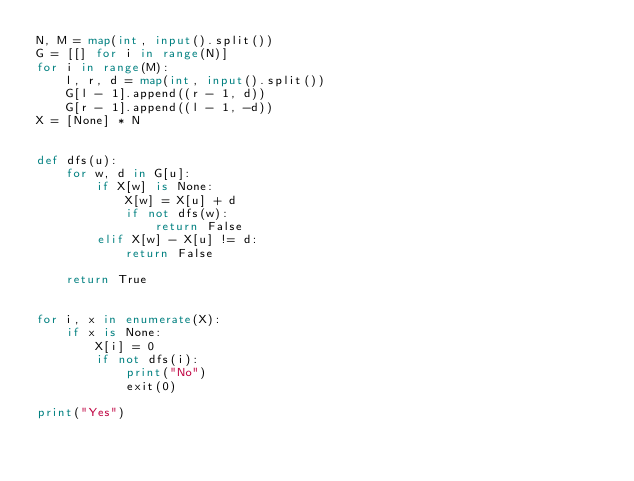Convert code to text. <code><loc_0><loc_0><loc_500><loc_500><_Python_>N, M = map(int, input().split())
G = [[] for i in range(N)]
for i in range(M):
    l, r, d = map(int, input().split())
    G[l - 1].append((r - 1, d))
    G[r - 1].append((l - 1, -d))
X = [None] * N


def dfs(u):
    for w, d in G[u]:
        if X[w] is None:
            X[w] = X[u] + d
            if not dfs(w):
                return False
        elif X[w] - X[u] != d:
            return False

    return True


for i, x in enumerate(X):
    if x is None:
        X[i] = 0
        if not dfs(i):
            print("No")
            exit(0)

print("Yes")</code> 